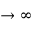<formula> <loc_0><loc_0><loc_500><loc_500>\rightarrow \infty</formula> 